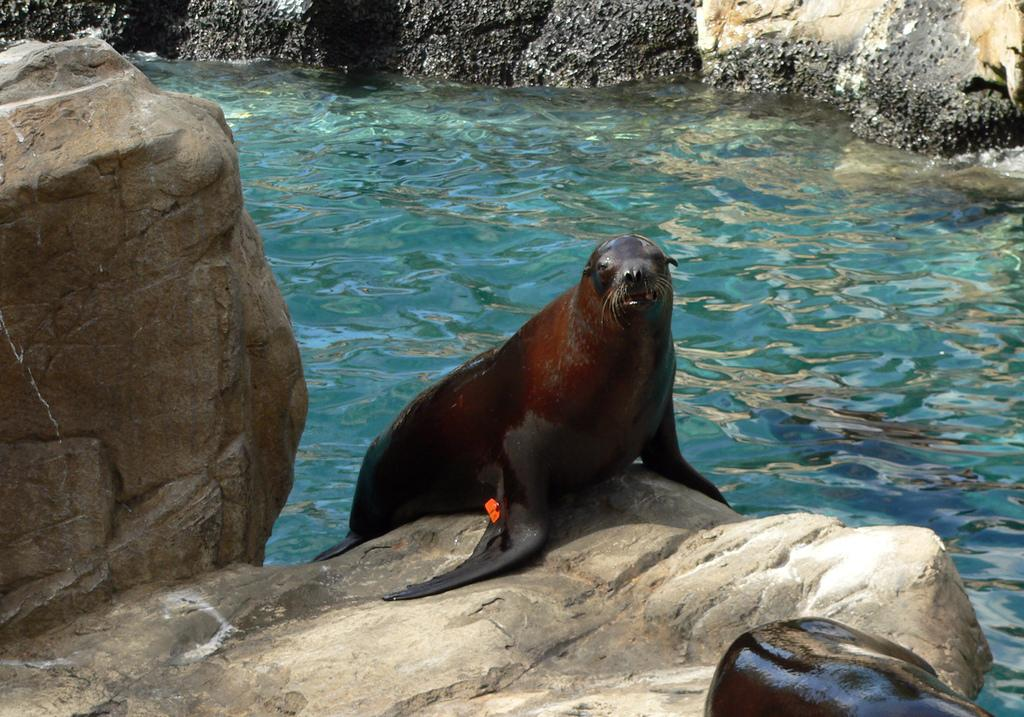What type of animal is in the center of the image? There is a water animal in the center of the image. What can be seen in the background of the image? There are rocks in the background of the image. What is the primary element visible in the image? There is water visible in the image. What other animal can be seen in the image? There is another animal in the front of the image. What color is the creature fighting in the image? There is no creature fighting in the image, and therefore no color can be associated with it. 